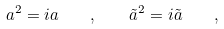<formula> <loc_0><loc_0><loc_500><loc_500>a ^ { 2 } = i a \quad , \quad { \tilde { a } } ^ { 2 } = i { \tilde { a } } \quad ,</formula> 